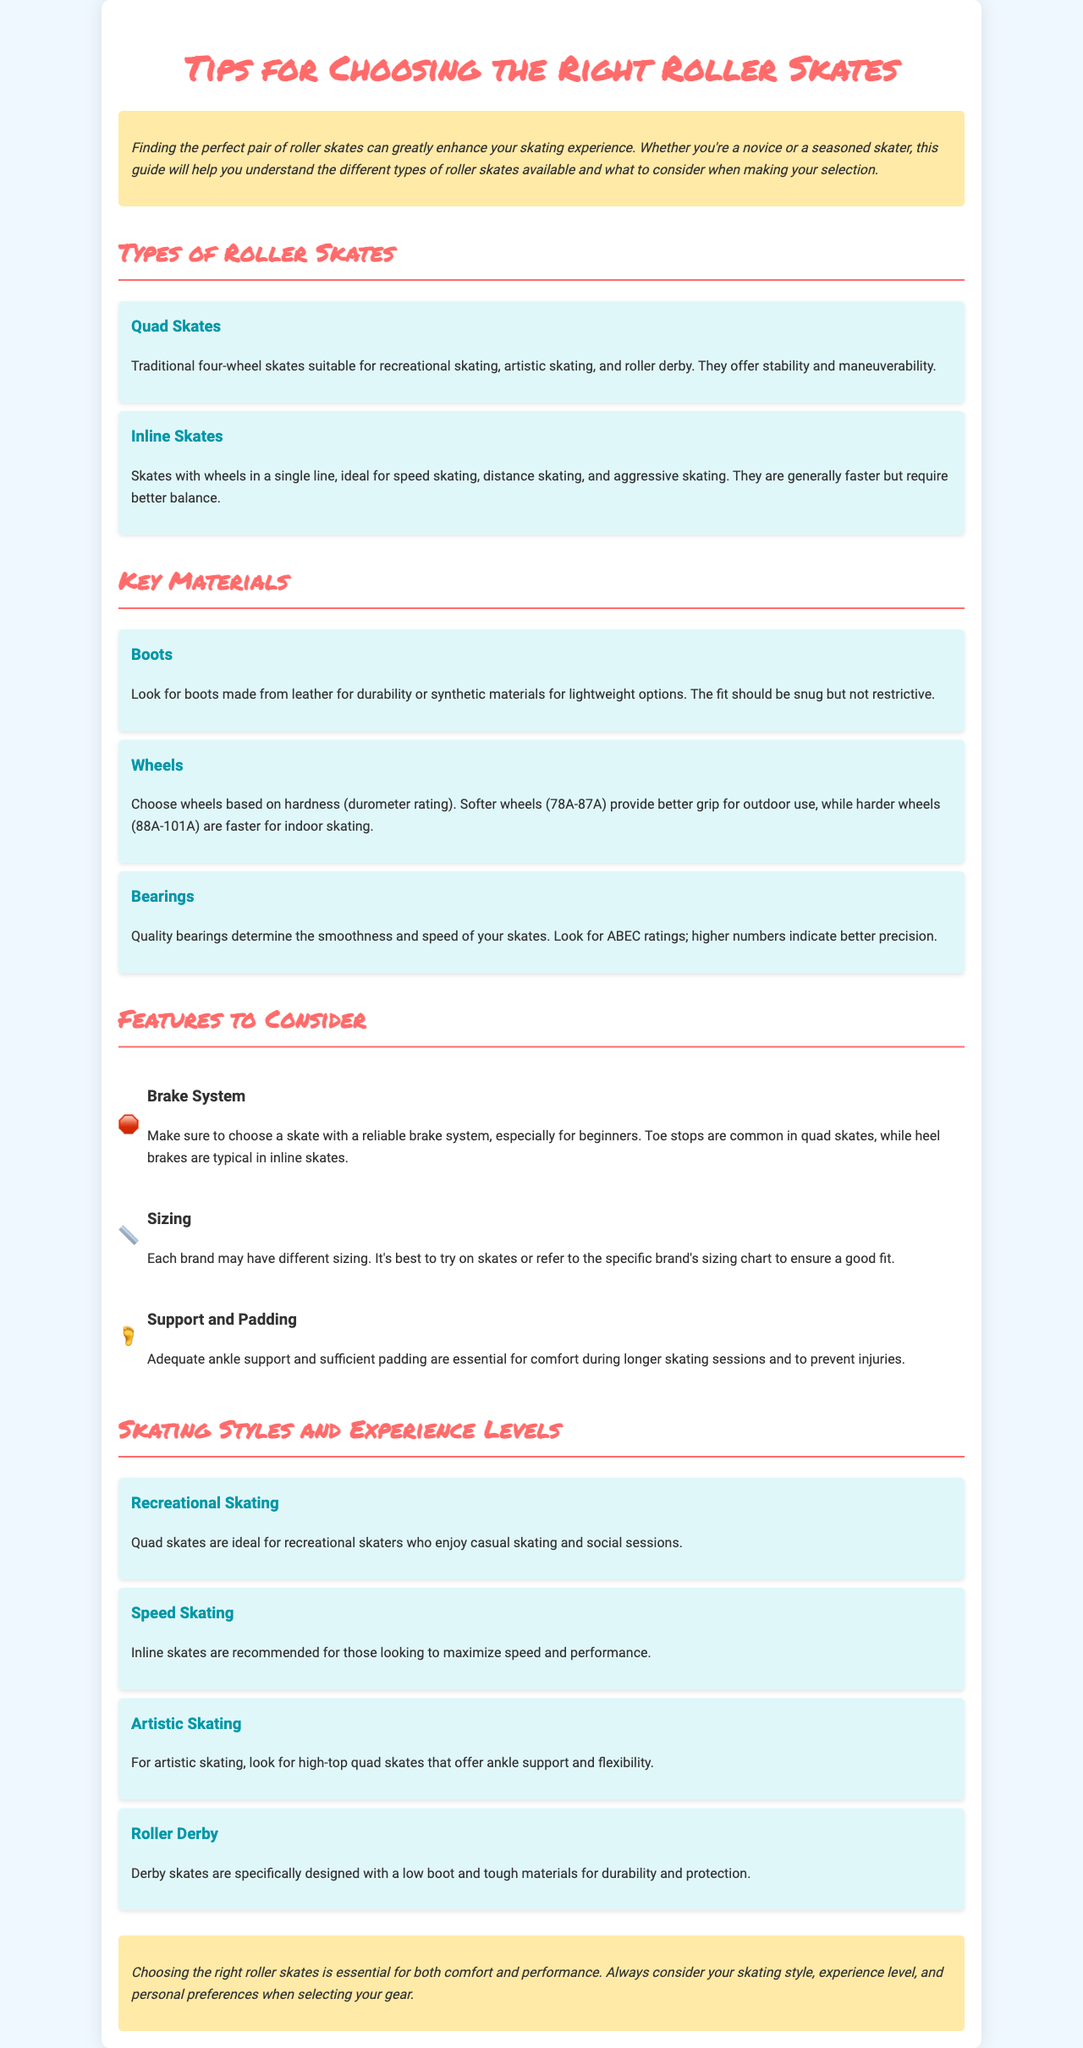What are the two types of roller skates mentioned? The document outlines two types of roller skates: Quad skates and Inline skates.
Answer: Quad skates, Inline skates What material is recommended for durable boots? The document suggests leather as a material for durable boots.
Answer: Leather What feature is essential for beginners in roller skates? The document recommends a reliable brake system as essential for beginners.
Answer: Brake system What durometer rating range is suggested for softer wheels? The document highlights a durometer rating of 78A-87A for softer wheels.
Answer: 78A-87A Which skating style is recommended for maximizing speed? The document states that Inline skates are recommended for speed skating.
Answer: Inline skates What should you look for in terms of fit? The document emphasizes that the fit should be snug but not restrictive.
Answer: Snug but not restrictive What type of skates are ideal for artistic skating? The document indicates that high-top quad skates are ideal for artistic skating.
Answer: High-top quad skates What should be considered when choosing roller skates? The document states that skating style, experience level, and personal preferences should be considered.
Answer: Skating style, experience level, personal preferences 